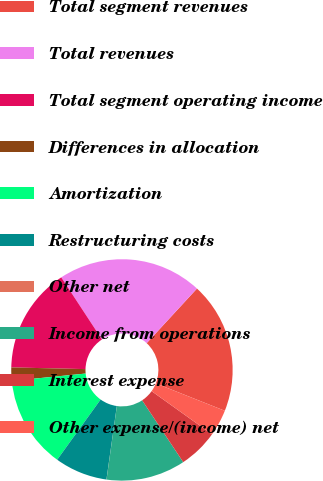<chart> <loc_0><loc_0><loc_500><loc_500><pie_chart><fcel>Total segment revenues<fcel>Total revenues<fcel>Total segment operating income<fcel>Differences in allocation<fcel>Amortization<fcel>Restructuring costs<fcel>Other net<fcel>Income from operations<fcel>Interest expense<fcel>Other expense/(income) net<nl><fcel>19.16%<fcel>21.09%<fcel>15.4%<fcel>1.94%<fcel>13.48%<fcel>7.71%<fcel>0.01%<fcel>11.56%<fcel>5.79%<fcel>3.86%<nl></chart> 